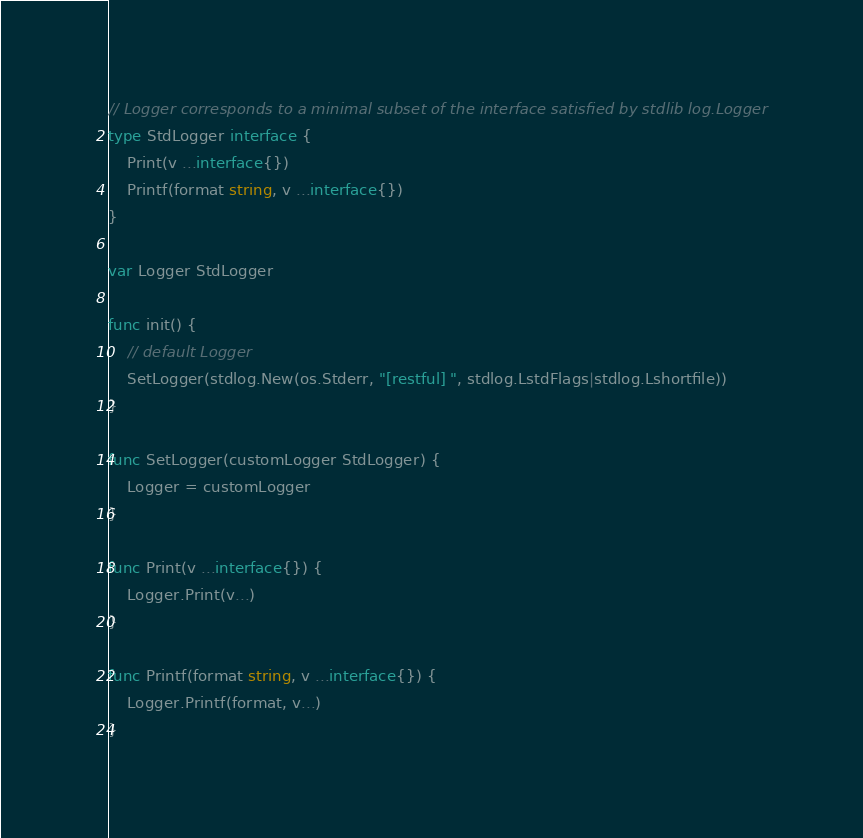<code> <loc_0><loc_0><loc_500><loc_500><_Go_>
// Logger corresponds to a minimal subset of the interface satisfied by stdlib log.Logger
type StdLogger interface {
	Print(v ...interface{})
	Printf(format string, v ...interface{})
}

var Logger StdLogger

func init() {
	// default Logger
	SetLogger(stdlog.New(os.Stderr, "[restful] ", stdlog.LstdFlags|stdlog.Lshortfile))
}

func SetLogger(customLogger StdLogger) {
	Logger = customLogger
}

func Print(v ...interface{}) {
	Logger.Print(v...)
}

func Printf(format string, v ...interface{}) {
	Logger.Printf(format, v...)
}
</code> 